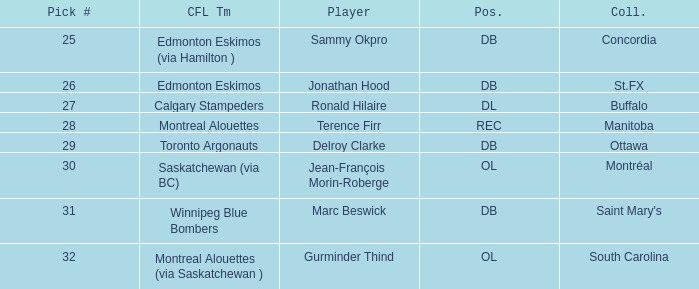Which CFL Team has a Pick # larger than 31? Montreal Alouettes (via Saskatchewan ). 